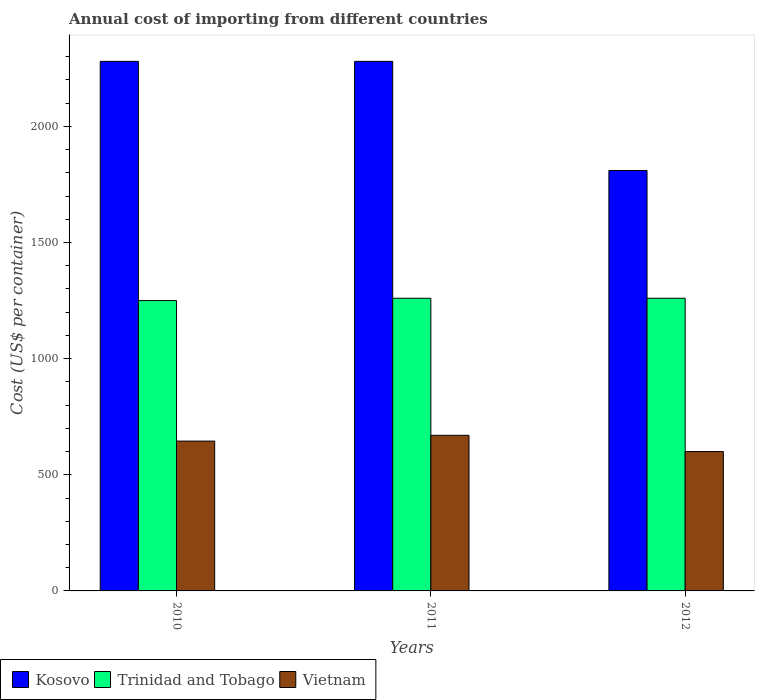How many bars are there on the 2nd tick from the left?
Provide a short and direct response. 3. How many bars are there on the 3rd tick from the right?
Provide a short and direct response. 3. What is the total annual cost of importing in Kosovo in 2012?
Your answer should be very brief. 1810. Across all years, what is the maximum total annual cost of importing in Trinidad and Tobago?
Your response must be concise. 1260. Across all years, what is the minimum total annual cost of importing in Kosovo?
Your answer should be very brief. 1810. What is the total total annual cost of importing in Kosovo in the graph?
Your answer should be compact. 6370. What is the difference between the total annual cost of importing in Kosovo in 2011 and that in 2012?
Offer a terse response. 470. What is the difference between the total annual cost of importing in Kosovo in 2011 and the total annual cost of importing in Vietnam in 2010?
Make the answer very short. 1635. What is the average total annual cost of importing in Vietnam per year?
Provide a short and direct response. 638.33. In the year 2011, what is the difference between the total annual cost of importing in Kosovo and total annual cost of importing in Vietnam?
Provide a succinct answer. 1610. In how many years, is the total annual cost of importing in Kosovo greater than 2200 US$?
Make the answer very short. 2. What is the ratio of the total annual cost of importing in Trinidad and Tobago in 2010 to that in 2012?
Provide a succinct answer. 0.99. Is the difference between the total annual cost of importing in Kosovo in 2011 and 2012 greater than the difference between the total annual cost of importing in Vietnam in 2011 and 2012?
Offer a very short reply. Yes. What is the difference between the highest and the lowest total annual cost of importing in Vietnam?
Make the answer very short. 70. In how many years, is the total annual cost of importing in Trinidad and Tobago greater than the average total annual cost of importing in Trinidad and Tobago taken over all years?
Offer a very short reply. 2. Is the sum of the total annual cost of importing in Trinidad and Tobago in 2011 and 2012 greater than the maximum total annual cost of importing in Kosovo across all years?
Provide a succinct answer. Yes. What does the 1st bar from the left in 2011 represents?
Provide a succinct answer. Kosovo. What does the 1st bar from the right in 2012 represents?
Your answer should be compact. Vietnam. Is it the case that in every year, the sum of the total annual cost of importing in Vietnam and total annual cost of importing in Trinidad and Tobago is greater than the total annual cost of importing in Kosovo?
Offer a very short reply. No. Are all the bars in the graph horizontal?
Your answer should be very brief. No. What is the difference between two consecutive major ticks on the Y-axis?
Offer a very short reply. 500. Does the graph contain any zero values?
Your answer should be very brief. No. Where does the legend appear in the graph?
Ensure brevity in your answer.  Bottom left. How many legend labels are there?
Provide a succinct answer. 3. What is the title of the graph?
Make the answer very short. Annual cost of importing from different countries. What is the label or title of the Y-axis?
Your answer should be compact. Cost (US$ per container). What is the Cost (US$ per container) of Kosovo in 2010?
Your answer should be compact. 2280. What is the Cost (US$ per container) in Trinidad and Tobago in 2010?
Keep it short and to the point. 1250. What is the Cost (US$ per container) of Vietnam in 2010?
Your answer should be compact. 645. What is the Cost (US$ per container) of Kosovo in 2011?
Your response must be concise. 2280. What is the Cost (US$ per container) in Trinidad and Tobago in 2011?
Your response must be concise. 1260. What is the Cost (US$ per container) in Vietnam in 2011?
Offer a very short reply. 670. What is the Cost (US$ per container) in Kosovo in 2012?
Provide a short and direct response. 1810. What is the Cost (US$ per container) in Trinidad and Tobago in 2012?
Keep it short and to the point. 1260. What is the Cost (US$ per container) in Vietnam in 2012?
Provide a succinct answer. 600. Across all years, what is the maximum Cost (US$ per container) in Kosovo?
Offer a very short reply. 2280. Across all years, what is the maximum Cost (US$ per container) in Trinidad and Tobago?
Offer a terse response. 1260. Across all years, what is the maximum Cost (US$ per container) of Vietnam?
Your answer should be compact. 670. Across all years, what is the minimum Cost (US$ per container) in Kosovo?
Your answer should be very brief. 1810. Across all years, what is the minimum Cost (US$ per container) of Trinidad and Tobago?
Give a very brief answer. 1250. Across all years, what is the minimum Cost (US$ per container) of Vietnam?
Offer a very short reply. 600. What is the total Cost (US$ per container) in Kosovo in the graph?
Your response must be concise. 6370. What is the total Cost (US$ per container) in Trinidad and Tobago in the graph?
Offer a terse response. 3770. What is the total Cost (US$ per container) in Vietnam in the graph?
Give a very brief answer. 1915. What is the difference between the Cost (US$ per container) of Vietnam in 2010 and that in 2011?
Provide a succinct answer. -25. What is the difference between the Cost (US$ per container) in Kosovo in 2010 and that in 2012?
Offer a terse response. 470. What is the difference between the Cost (US$ per container) in Kosovo in 2011 and that in 2012?
Ensure brevity in your answer.  470. What is the difference between the Cost (US$ per container) in Vietnam in 2011 and that in 2012?
Provide a short and direct response. 70. What is the difference between the Cost (US$ per container) in Kosovo in 2010 and the Cost (US$ per container) in Trinidad and Tobago in 2011?
Your response must be concise. 1020. What is the difference between the Cost (US$ per container) in Kosovo in 2010 and the Cost (US$ per container) in Vietnam in 2011?
Ensure brevity in your answer.  1610. What is the difference between the Cost (US$ per container) of Trinidad and Tobago in 2010 and the Cost (US$ per container) of Vietnam in 2011?
Provide a short and direct response. 580. What is the difference between the Cost (US$ per container) in Kosovo in 2010 and the Cost (US$ per container) in Trinidad and Tobago in 2012?
Your answer should be compact. 1020. What is the difference between the Cost (US$ per container) in Kosovo in 2010 and the Cost (US$ per container) in Vietnam in 2012?
Your response must be concise. 1680. What is the difference between the Cost (US$ per container) in Trinidad and Tobago in 2010 and the Cost (US$ per container) in Vietnam in 2012?
Make the answer very short. 650. What is the difference between the Cost (US$ per container) of Kosovo in 2011 and the Cost (US$ per container) of Trinidad and Tobago in 2012?
Ensure brevity in your answer.  1020. What is the difference between the Cost (US$ per container) of Kosovo in 2011 and the Cost (US$ per container) of Vietnam in 2012?
Provide a short and direct response. 1680. What is the difference between the Cost (US$ per container) in Trinidad and Tobago in 2011 and the Cost (US$ per container) in Vietnam in 2012?
Offer a terse response. 660. What is the average Cost (US$ per container) of Kosovo per year?
Your answer should be compact. 2123.33. What is the average Cost (US$ per container) in Trinidad and Tobago per year?
Make the answer very short. 1256.67. What is the average Cost (US$ per container) in Vietnam per year?
Your response must be concise. 638.33. In the year 2010, what is the difference between the Cost (US$ per container) of Kosovo and Cost (US$ per container) of Trinidad and Tobago?
Offer a terse response. 1030. In the year 2010, what is the difference between the Cost (US$ per container) of Kosovo and Cost (US$ per container) of Vietnam?
Your answer should be very brief. 1635. In the year 2010, what is the difference between the Cost (US$ per container) of Trinidad and Tobago and Cost (US$ per container) of Vietnam?
Keep it short and to the point. 605. In the year 2011, what is the difference between the Cost (US$ per container) in Kosovo and Cost (US$ per container) in Trinidad and Tobago?
Offer a very short reply. 1020. In the year 2011, what is the difference between the Cost (US$ per container) of Kosovo and Cost (US$ per container) of Vietnam?
Provide a succinct answer. 1610. In the year 2011, what is the difference between the Cost (US$ per container) in Trinidad and Tobago and Cost (US$ per container) in Vietnam?
Offer a very short reply. 590. In the year 2012, what is the difference between the Cost (US$ per container) of Kosovo and Cost (US$ per container) of Trinidad and Tobago?
Offer a very short reply. 550. In the year 2012, what is the difference between the Cost (US$ per container) in Kosovo and Cost (US$ per container) in Vietnam?
Your answer should be very brief. 1210. In the year 2012, what is the difference between the Cost (US$ per container) in Trinidad and Tobago and Cost (US$ per container) in Vietnam?
Offer a terse response. 660. What is the ratio of the Cost (US$ per container) of Kosovo in 2010 to that in 2011?
Offer a terse response. 1. What is the ratio of the Cost (US$ per container) in Trinidad and Tobago in 2010 to that in 2011?
Provide a short and direct response. 0.99. What is the ratio of the Cost (US$ per container) in Vietnam in 2010 to that in 2011?
Offer a very short reply. 0.96. What is the ratio of the Cost (US$ per container) in Kosovo in 2010 to that in 2012?
Make the answer very short. 1.26. What is the ratio of the Cost (US$ per container) in Trinidad and Tobago in 2010 to that in 2012?
Keep it short and to the point. 0.99. What is the ratio of the Cost (US$ per container) in Vietnam in 2010 to that in 2012?
Offer a terse response. 1.07. What is the ratio of the Cost (US$ per container) in Kosovo in 2011 to that in 2012?
Provide a short and direct response. 1.26. What is the ratio of the Cost (US$ per container) in Trinidad and Tobago in 2011 to that in 2012?
Your answer should be very brief. 1. What is the ratio of the Cost (US$ per container) of Vietnam in 2011 to that in 2012?
Give a very brief answer. 1.12. What is the difference between the highest and the second highest Cost (US$ per container) of Trinidad and Tobago?
Give a very brief answer. 0. What is the difference between the highest and the second highest Cost (US$ per container) of Vietnam?
Keep it short and to the point. 25. What is the difference between the highest and the lowest Cost (US$ per container) of Kosovo?
Offer a terse response. 470. What is the difference between the highest and the lowest Cost (US$ per container) in Trinidad and Tobago?
Your answer should be very brief. 10. What is the difference between the highest and the lowest Cost (US$ per container) of Vietnam?
Ensure brevity in your answer.  70. 